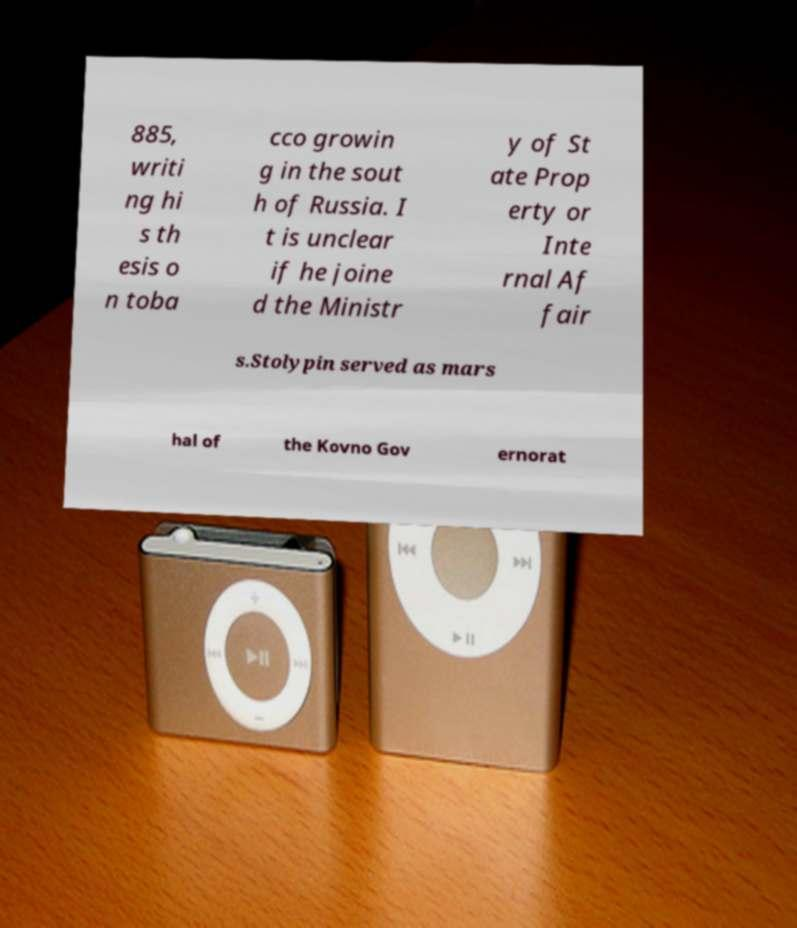For documentation purposes, I need the text within this image transcribed. Could you provide that? 885, writi ng hi s th esis o n toba cco growin g in the sout h of Russia. I t is unclear if he joine d the Ministr y of St ate Prop erty or Inte rnal Af fair s.Stolypin served as mars hal of the Kovno Gov ernorat 